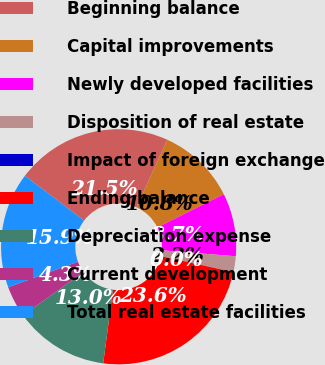Convert chart. <chart><loc_0><loc_0><loc_500><loc_500><pie_chart><fcel>Beginning balance<fcel>Capital improvements<fcel>Newly developed facilities<fcel>Disposition of real estate<fcel>Impact of foreign exchange<fcel>Ending balance<fcel>Depreciation expense<fcel>Current development<fcel>Total real estate facilities<nl><fcel>21.47%<fcel>10.83%<fcel>8.66%<fcel>2.17%<fcel>0.0%<fcel>23.63%<fcel>12.99%<fcel>4.33%<fcel>15.91%<nl></chart> 